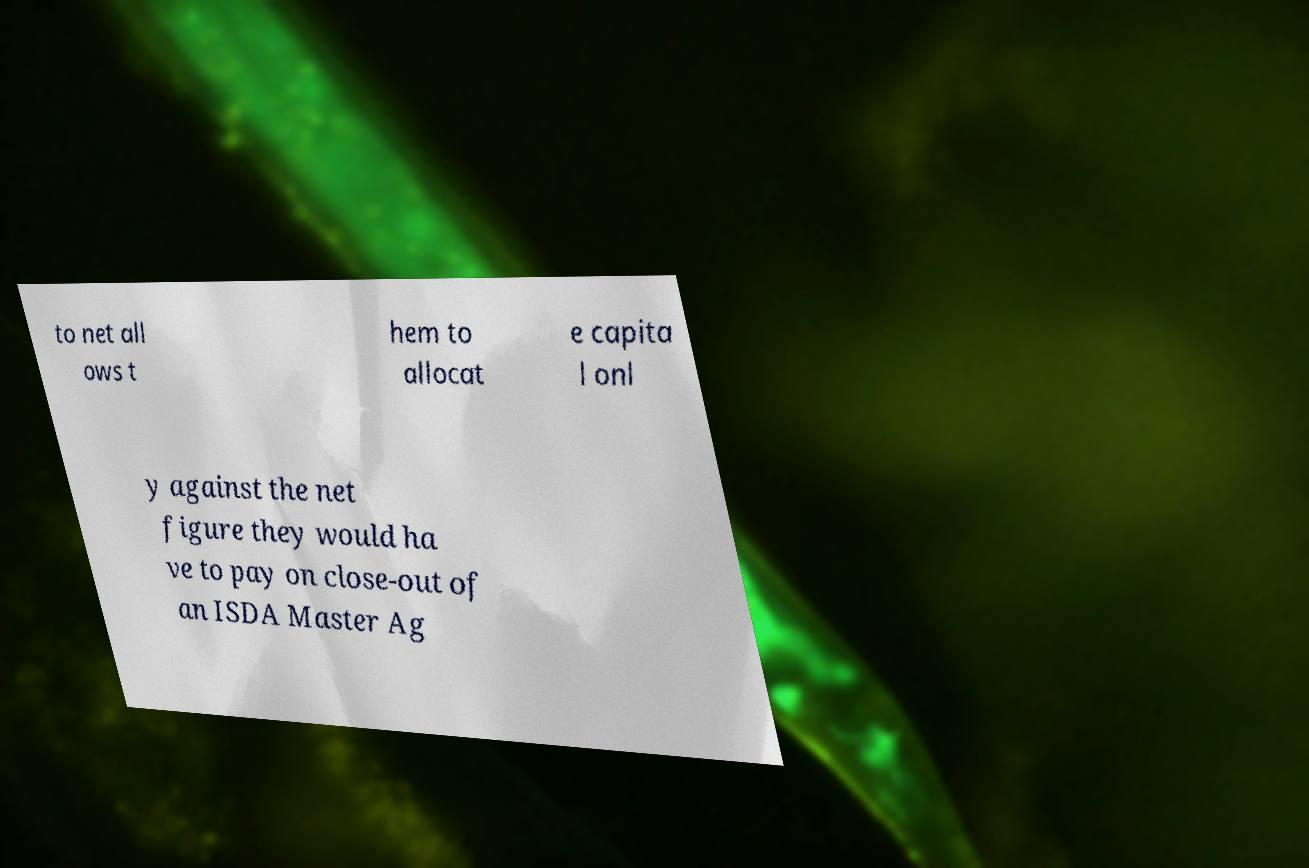There's text embedded in this image that I need extracted. Can you transcribe it verbatim? to net all ows t hem to allocat e capita l onl y against the net figure they would ha ve to pay on close-out of an ISDA Master Ag 